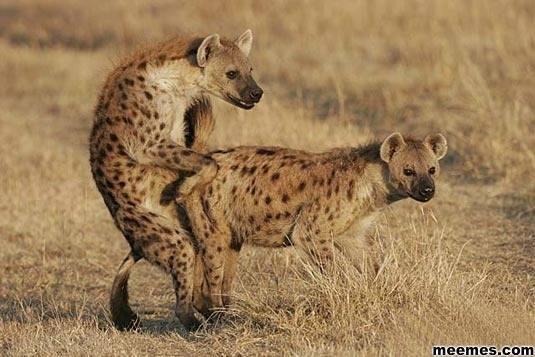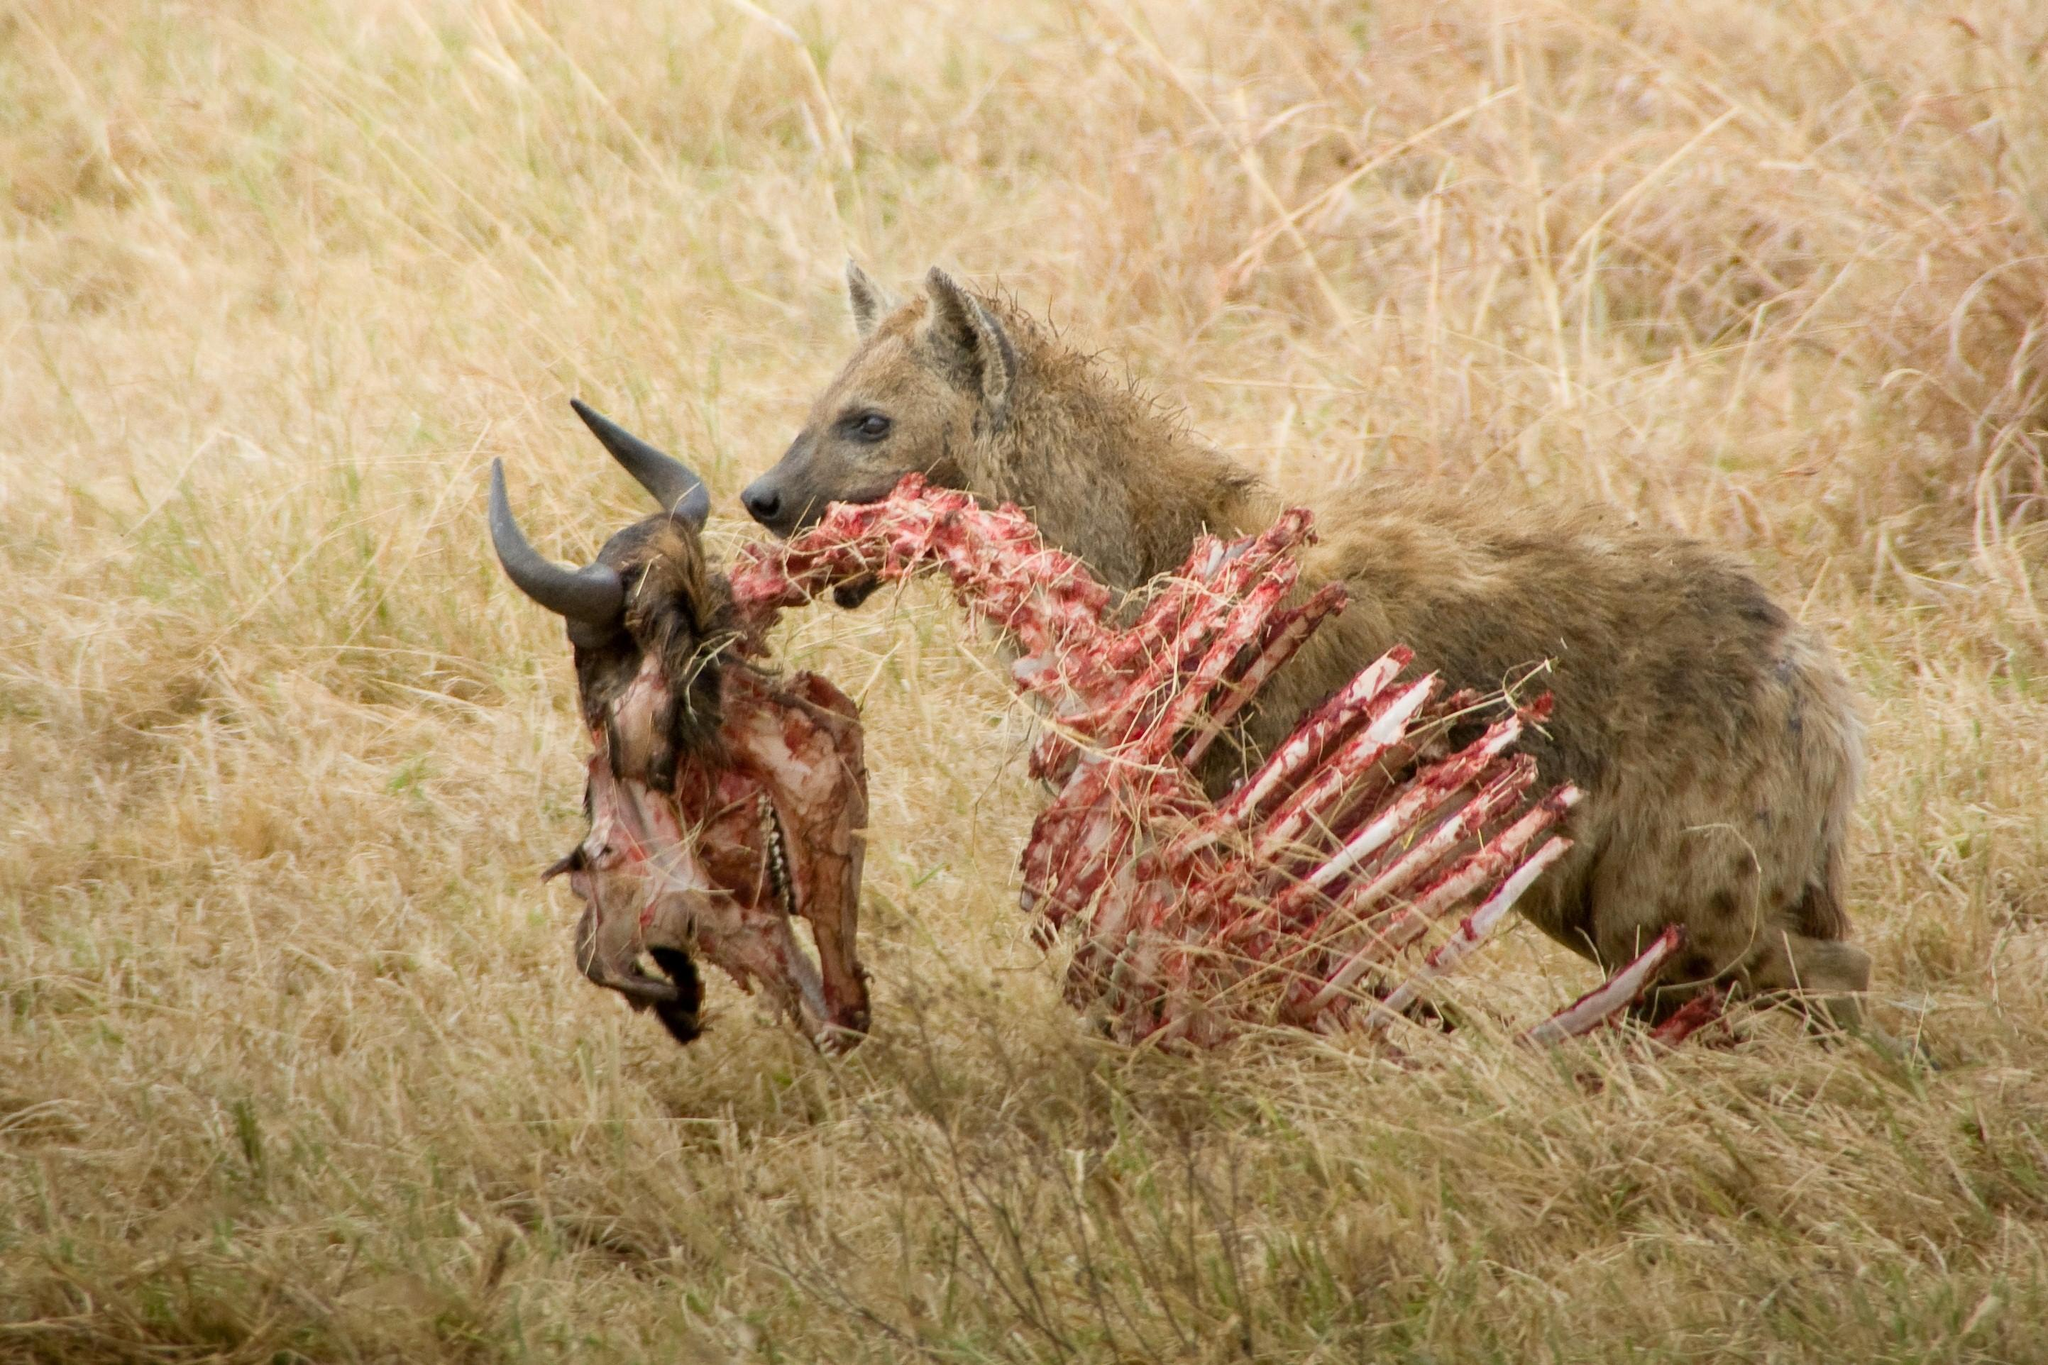The first image is the image on the left, the second image is the image on the right. Assess this claim about the two images: "There are exactly two animals in the image on the left.". Correct or not? Answer yes or no. Yes. 